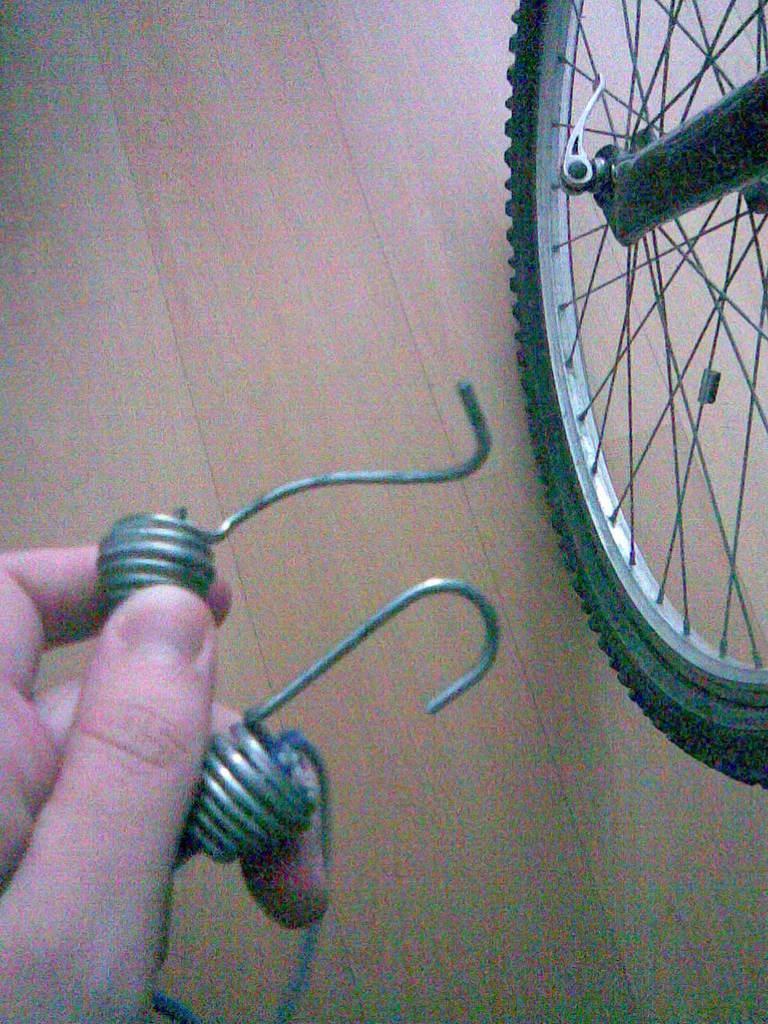In one or two sentences, can you explain what this image depicts? In this picture we can observe a wheel of a bicycle on the floor. The floor is in cream color. We can observe a human hand holding two springs. 